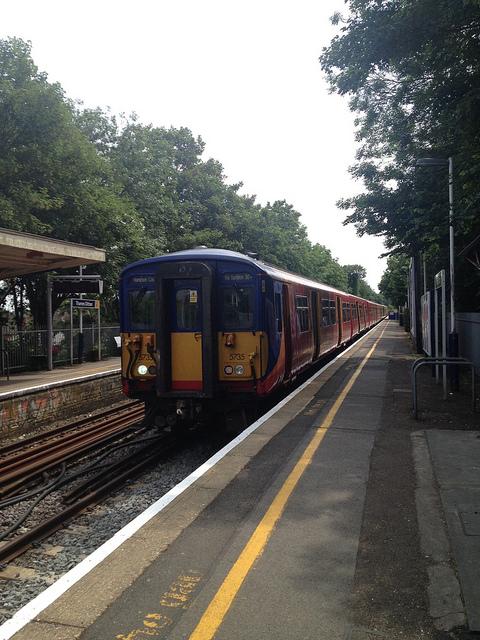How many passengers do you think the train can hold?
Keep it brief. 300. Does the train have lights?
Give a very brief answer. Yes. Is the train in motion?
Short answer required. No. 